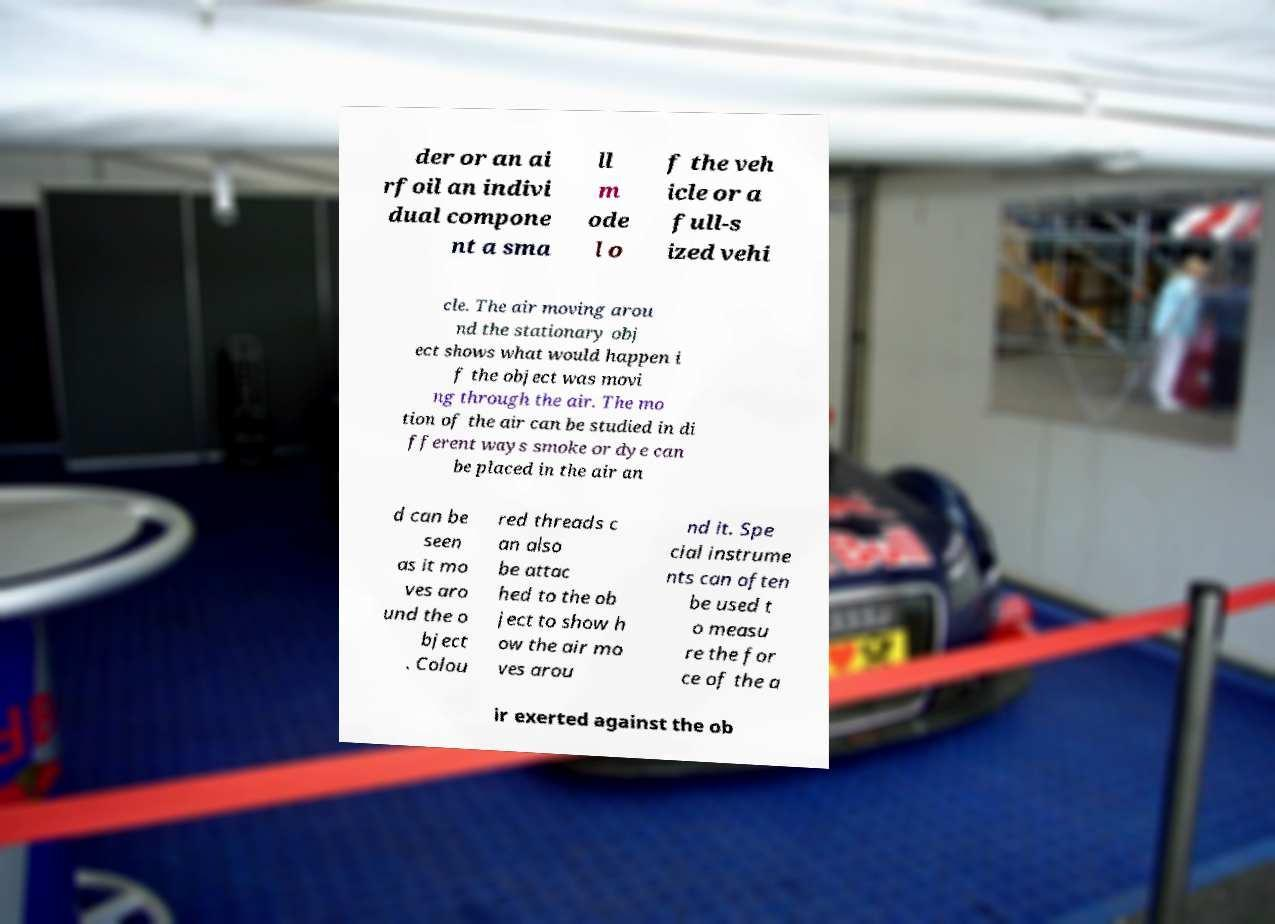Could you extract and type out the text from this image? der or an ai rfoil an indivi dual compone nt a sma ll m ode l o f the veh icle or a full-s ized vehi cle. The air moving arou nd the stationary obj ect shows what would happen i f the object was movi ng through the air. The mo tion of the air can be studied in di fferent ways smoke or dye can be placed in the air an d can be seen as it mo ves aro und the o bject . Colou red threads c an also be attac hed to the ob ject to show h ow the air mo ves arou nd it. Spe cial instrume nts can often be used t o measu re the for ce of the a ir exerted against the ob 